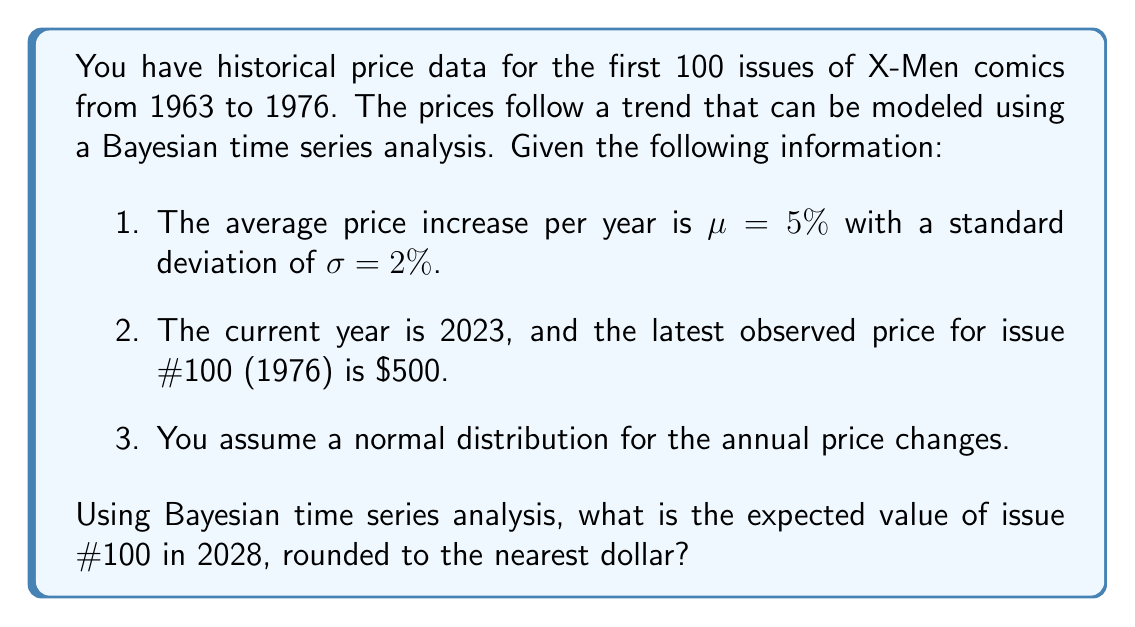Give your solution to this math problem. To solve this problem, we'll use Bayesian time series analysis to predict the future value of the comic book. Here's a step-by-step approach:

1. Define the model:
   Let $P_t$ be the price at time $t$, and $r_t$ be the annual return rate.
   $$P_t = P_{t-1} \cdot (1 + r_t)$$
   where $r_t \sim N(\mu, \sigma^2)$

2. Given information:
   $\mu = 5\% = 0.05$
   $\sigma = 2\% = 0.02$
   Current year: 2023
   Target year: 2028
   Time difference: 5 years
   Latest observed price (2023): $500

3. Calculate the expected value:
   The expected value after 5 years can be computed as:
   $$E[P_{2028}] = P_{2023} \cdot (1 + \mu)^5$$

   Substituting the values:
   $$E[P_{2028}] = 500 \cdot (1 + 0.05)^5$$

4. Compute the result:
   $$E[P_{2028}] = 500 \cdot (1.05)^5$$
   $$E[P_{2028}] = 500 \cdot 1.2762815625$$
   $$E[P_{2028}] = 638.14078125$$

5. Round to the nearest dollar:
   $$E[P_{2028}] \approx 638$$

Note: This calculation assumes that the historical trend will continue in the future, which may not always be the case in real-world scenarios. Additionally, a more complex Bayesian model could incorporate uncertainty in the parameters and provide a distribution of possible future values rather than a point estimate.
Answer: $638 